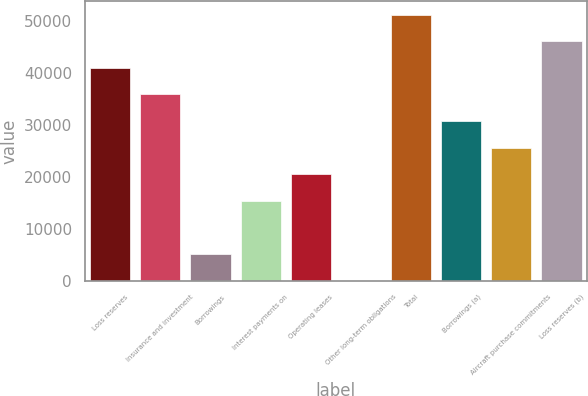Convert chart to OTSL. <chart><loc_0><loc_0><loc_500><loc_500><bar_chart><fcel>Loss reserves<fcel>Insurance and investment<fcel>Borrowings<fcel>Interest payments on<fcel>Operating leases<fcel>Other long-term obligations<fcel>Total<fcel>Borrowings (a)<fcel>Aircraft purchase commitments<fcel>Loss reserves (b)<nl><fcel>41041<fcel>35912<fcel>5138<fcel>15396<fcel>20525<fcel>9<fcel>51299<fcel>30783<fcel>25654<fcel>46170<nl></chart> 